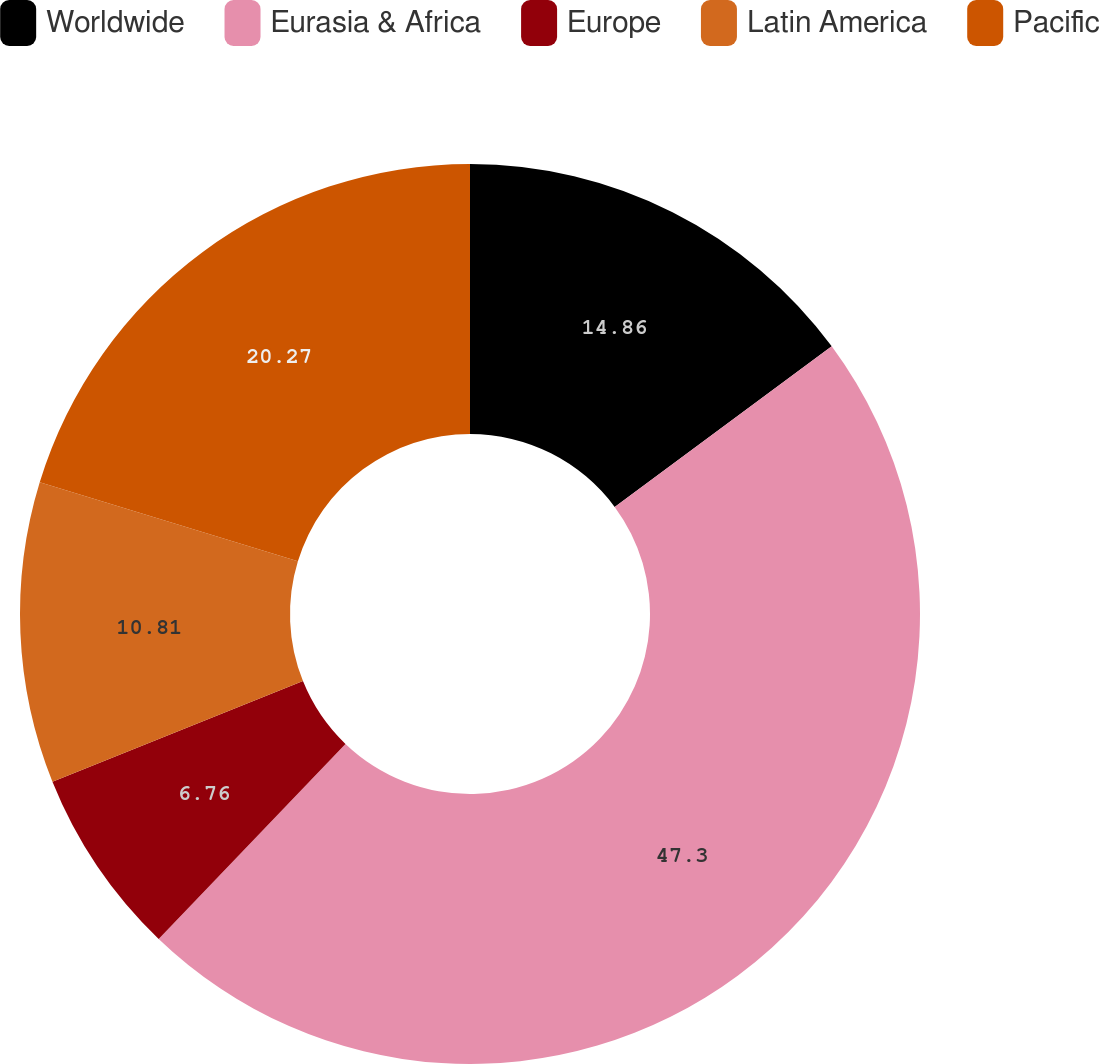Convert chart to OTSL. <chart><loc_0><loc_0><loc_500><loc_500><pie_chart><fcel>Worldwide<fcel>Eurasia & Africa<fcel>Europe<fcel>Latin America<fcel>Pacific<nl><fcel>14.86%<fcel>47.3%<fcel>6.76%<fcel>10.81%<fcel>20.27%<nl></chart> 